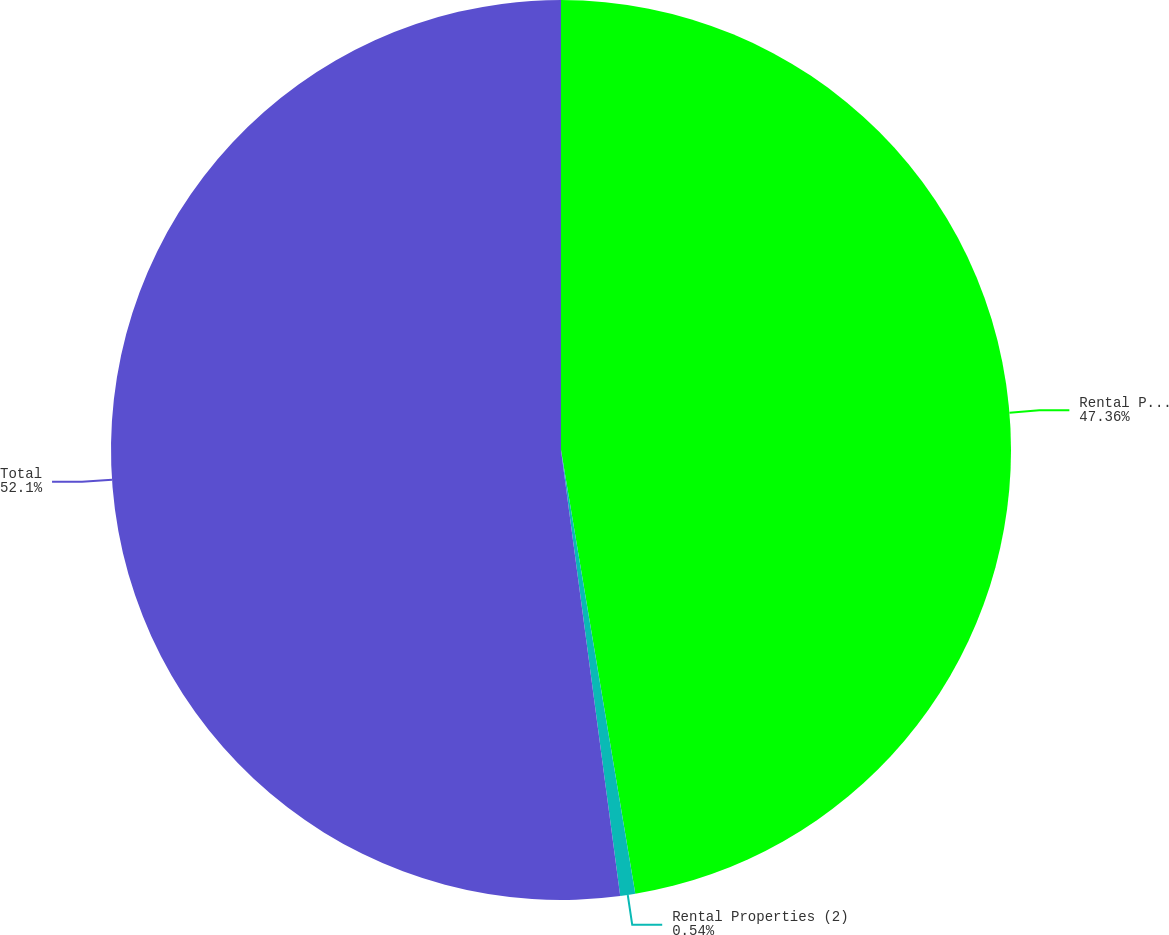<chart> <loc_0><loc_0><loc_500><loc_500><pie_chart><fcel>Rental Properties (1)<fcel>Rental Properties (2)<fcel>Total<nl><fcel>47.36%<fcel>0.54%<fcel>52.1%<nl></chart> 